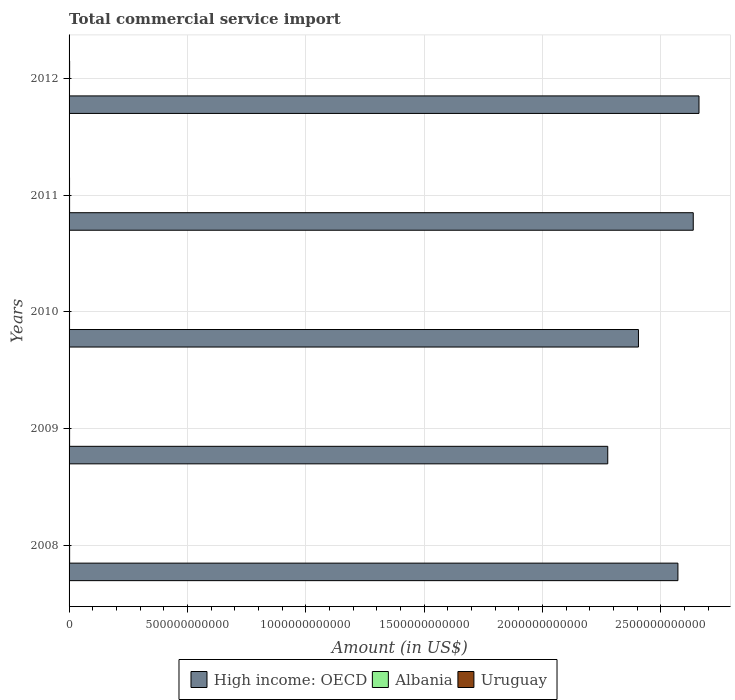Are the number of bars per tick equal to the number of legend labels?
Offer a very short reply. Yes. How many bars are there on the 1st tick from the top?
Provide a succinct answer. 3. In how many cases, is the number of bars for a given year not equal to the number of legend labels?
Ensure brevity in your answer.  0. What is the total commercial service import in Albania in 2011?
Your answer should be compact. 2.24e+09. Across all years, what is the maximum total commercial service import in Albania?
Make the answer very short. 2.35e+09. Across all years, what is the minimum total commercial service import in High income: OECD?
Your answer should be very brief. 2.28e+12. In which year was the total commercial service import in Uruguay minimum?
Offer a terse response. 2009. What is the total total commercial service import in High income: OECD in the graph?
Offer a very short reply. 1.26e+13. What is the difference between the total commercial service import in Uruguay in 2008 and that in 2012?
Make the answer very short. -8.85e+08. What is the difference between the total commercial service import in Uruguay in 2010 and the total commercial service import in High income: OECD in 2011?
Make the answer very short. -2.64e+12. What is the average total commercial service import in High income: OECD per year?
Offer a very short reply. 2.51e+12. In the year 2009, what is the difference between the total commercial service import in High income: OECD and total commercial service import in Albania?
Ensure brevity in your answer.  2.27e+12. In how many years, is the total commercial service import in High income: OECD greater than 300000000000 US$?
Ensure brevity in your answer.  5. What is the ratio of the total commercial service import in Albania in 2010 to that in 2012?
Your answer should be very brief. 1.07. Is the total commercial service import in High income: OECD in 2009 less than that in 2012?
Provide a short and direct response. Yes. Is the difference between the total commercial service import in High income: OECD in 2009 and 2010 greater than the difference between the total commercial service import in Albania in 2009 and 2010?
Provide a succinct answer. No. What is the difference between the highest and the second highest total commercial service import in Uruguay?
Keep it short and to the point. 3.33e+08. What is the difference between the highest and the lowest total commercial service import in Albania?
Provide a short and direct response. 4.93e+08. In how many years, is the total commercial service import in High income: OECD greater than the average total commercial service import in High income: OECD taken over all years?
Your answer should be compact. 3. What does the 1st bar from the top in 2009 represents?
Provide a short and direct response. Uruguay. What does the 3rd bar from the bottom in 2008 represents?
Give a very brief answer. Uruguay. How many bars are there?
Your response must be concise. 15. What is the difference between two consecutive major ticks on the X-axis?
Your answer should be compact. 5.00e+11. How are the legend labels stacked?
Keep it short and to the point. Horizontal. What is the title of the graph?
Make the answer very short. Total commercial service import. Does "Kenya" appear as one of the legend labels in the graph?
Keep it short and to the point. No. What is the Amount (in US$) of High income: OECD in 2008?
Make the answer very short. 2.57e+12. What is the Amount (in US$) in Albania in 2008?
Provide a succinct answer. 2.35e+09. What is the Amount (in US$) of Uruguay in 2008?
Ensure brevity in your answer.  1.46e+09. What is the Amount (in US$) of High income: OECD in 2009?
Your response must be concise. 2.28e+12. What is the Amount (in US$) of Albania in 2009?
Ensure brevity in your answer.  2.22e+09. What is the Amount (in US$) in Uruguay in 2009?
Your answer should be very brief. 1.23e+09. What is the Amount (in US$) of High income: OECD in 2010?
Offer a very short reply. 2.41e+12. What is the Amount (in US$) of Albania in 2010?
Make the answer very short. 1.99e+09. What is the Amount (in US$) of Uruguay in 2010?
Ensure brevity in your answer.  1.47e+09. What is the Amount (in US$) in High income: OECD in 2011?
Provide a short and direct response. 2.64e+12. What is the Amount (in US$) in Albania in 2011?
Offer a very short reply. 2.24e+09. What is the Amount (in US$) of Uruguay in 2011?
Keep it short and to the point. 2.01e+09. What is the Amount (in US$) of High income: OECD in 2012?
Your answer should be very brief. 2.66e+12. What is the Amount (in US$) of Albania in 2012?
Your answer should be compact. 1.86e+09. What is the Amount (in US$) of Uruguay in 2012?
Offer a terse response. 2.35e+09. Across all years, what is the maximum Amount (in US$) in High income: OECD?
Your answer should be compact. 2.66e+12. Across all years, what is the maximum Amount (in US$) in Albania?
Your answer should be compact. 2.35e+09. Across all years, what is the maximum Amount (in US$) in Uruguay?
Provide a short and direct response. 2.35e+09. Across all years, what is the minimum Amount (in US$) in High income: OECD?
Your answer should be very brief. 2.28e+12. Across all years, what is the minimum Amount (in US$) of Albania?
Your answer should be compact. 1.86e+09. Across all years, what is the minimum Amount (in US$) in Uruguay?
Keep it short and to the point. 1.23e+09. What is the total Amount (in US$) of High income: OECD in the graph?
Offer a terse response. 1.26e+13. What is the total Amount (in US$) in Albania in the graph?
Provide a succinct answer. 1.07e+1. What is the total Amount (in US$) of Uruguay in the graph?
Give a very brief answer. 8.53e+09. What is the difference between the Amount (in US$) of High income: OECD in 2008 and that in 2009?
Make the answer very short. 2.97e+11. What is the difference between the Amount (in US$) of Albania in 2008 and that in 2009?
Make the answer very short. 1.38e+08. What is the difference between the Amount (in US$) of Uruguay in 2008 and that in 2009?
Make the answer very short. 2.29e+08. What is the difference between the Amount (in US$) in High income: OECD in 2008 and that in 2010?
Your answer should be compact. 1.67e+11. What is the difference between the Amount (in US$) in Albania in 2008 and that in 2010?
Your answer should be very brief. 3.65e+08. What is the difference between the Amount (in US$) of Uruguay in 2008 and that in 2010?
Keep it short and to the point. -7.59e+06. What is the difference between the Amount (in US$) of High income: OECD in 2008 and that in 2011?
Your answer should be compact. -6.48e+1. What is the difference between the Amount (in US$) in Albania in 2008 and that in 2011?
Your answer should be compact. 1.18e+08. What is the difference between the Amount (in US$) in Uruguay in 2008 and that in 2011?
Your response must be concise. -5.52e+08. What is the difference between the Amount (in US$) in High income: OECD in 2008 and that in 2012?
Your response must be concise. -8.90e+1. What is the difference between the Amount (in US$) of Albania in 2008 and that in 2012?
Ensure brevity in your answer.  4.93e+08. What is the difference between the Amount (in US$) in Uruguay in 2008 and that in 2012?
Keep it short and to the point. -8.85e+08. What is the difference between the Amount (in US$) in High income: OECD in 2009 and that in 2010?
Provide a short and direct response. -1.30e+11. What is the difference between the Amount (in US$) in Albania in 2009 and that in 2010?
Keep it short and to the point. 2.27e+08. What is the difference between the Amount (in US$) of Uruguay in 2009 and that in 2010?
Your answer should be very brief. -2.36e+08. What is the difference between the Amount (in US$) in High income: OECD in 2009 and that in 2011?
Give a very brief answer. -3.61e+11. What is the difference between the Amount (in US$) of Albania in 2009 and that in 2011?
Provide a short and direct response. -1.96e+07. What is the difference between the Amount (in US$) of Uruguay in 2009 and that in 2011?
Make the answer very short. -7.80e+08. What is the difference between the Amount (in US$) of High income: OECD in 2009 and that in 2012?
Offer a terse response. -3.86e+11. What is the difference between the Amount (in US$) in Albania in 2009 and that in 2012?
Provide a succinct answer. 3.55e+08. What is the difference between the Amount (in US$) of Uruguay in 2009 and that in 2012?
Your answer should be compact. -1.11e+09. What is the difference between the Amount (in US$) in High income: OECD in 2010 and that in 2011?
Give a very brief answer. -2.32e+11. What is the difference between the Amount (in US$) in Albania in 2010 and that in 2011?
Give a very brief answer. -2.47e+08. What is the difference between the Amount (in US$) of Uruguay in 2010 and that in 2011?
Make the answer very short. -5.44e+08. What is the difference between the Amount (in US$) in High income: OECD in 2010 and that in 2012?
Give a very brief answer. -2.56e+11. What is the difference between the Amount (in US$) in Albania in 2010 and that in 2012?
Offer a very short reply. 1.28e+08. What is the difference between the Amount (in US$) in Uruguay in 2010 and that in 2012?
Give a very brief answer. -8.77e+08. What is the difference between the Amount (in US$) of High income: OECD in 2011 and that in 2012?
Your answer should be compact. -2.43e+1. What is the difference between the Amount (in US$) in Albania in 2011 and that in 2012?
Provide a short and direct response. 3.75e+08. What is the difference between the Amount (in US$) in Uruguay in 2011 and that in 2012?
Make the answer very short. -3.33e+08. What is the difference between the Amount (in US$) of High income: OECD in 2008 and the Amount (in US$) of Albania in 2009?
Your answer should be very brief. 2.57e+12. What is the difference between the Amount (in US$) in High income: OECD in 2008 and the Amount (in US$) in Uruguay in 2009?
Offer a very short reply. 2.57e+12. What is the difference between the Amount (in US$) in Albania in 2008 and the Amount (in US$) in Uruguay in 2009?
Ensure brevity in your answer.  1.12e+09. What is the difference between the Amount (in US$) of High income: OECD in 2008 and the Amount (in US$) of Albania in 2010?
Your response must be concise. 2.57e+12. What is the difference between the Amount (in US$) in High income: OECD in 2008 and the Amount (in US$) in Uruguay in 2010?
Keep it short and to the point. 2.57e+12. What is the difference between the Amount (in US$) in Albania in 2008 and the Amount (in US$) in Uruguay in 2010?
Give a very brief answer. 8.84e+08. What is the difference between the Amount (in US$) in High income: OECD in 2008 and the Amount (in US$) in Albania in 2011?
Offer a very short reply. 2.57e+12. What is the difference between the Amount (in US$) of High income: OECD in 2008 and the Amount (in US$) of Uruguay in 2011?
Your response must be concise. 2.57e+12. What is the difference between the Amount (in US$) of Albania in 2008 and the Amount (in US$) of Uruguay in 2011?
Provide a short and direct response. 3.40e+08. What is the difference between the Amount (in US$) of High income: OECD in 2008 and the Amount (in US$) of Albania in 2012?
Offer a terse response. 2.57e+12. What is the difference between the Amount (in US$) in High income: OECD in 2008 and the Amount (in US$) in Uruguay in 2012?
Your response must be concise. 2.57e+12. What is the difference between the Amount (in US$) in Albania in 2008 and the Amount (in US$) in Uruguay in 2012?
Ensure brevity in your answer.  6.91e+06. What is the difference between the Amount (in US$) of High income: OECD in 2009 and the Amount (in US$) of Albania in 2010?
Offer a very short reply. 2.27e+12. What is the difference between the Amount (in US$) of High income: OECD in 2009 and the Amount (in US$) of Uruguay in 2010?
Make the answer very short. 2.27e+12. What is the difference between the Amount (in US$) of Albania in 2009 and the Amount (in US$) of Uruguay in 2010?
Offer a very short reply. 7.46e+08. What is the difference between the Amount (in US$) in High income: OECD in 2009 and the Amount (in US$) in Albania in 2011?
Offer a terse response. 2.27e+12. What is the difference between the Amount (in US$) of High income: OECD in 2009 and the Amount (in US$) of Uruguay in 2011?
Offer a terse response. 2.27e+12. What is the difference between the Amount (in US$) of Albania in 2009 and the Amount (in US$) of Uruguay in 2011?
Keep it short and to the point. 2.02e+08. What is the difference between the Amount (in US$) of High income: OECD in 2009 and the Amount (in US$) of Albania in 2012?
Your answer should be very brief. 2.27e+12. What is the difference between the Amount (in US$) of High income: OECD in 2009 and the Amount (in US$) of Uruguay in 2012?
Ensure brevity in your answer.  2.27e+12. What is the difference between the Amount (in US$) of Albania in 2009 and the Amount (in US$) of Uruguay in 2012?
Offer a terse response. -1.31e+08. What is the difference between the Amount (in US$) of High income: OECD in 2010 and the Amount (in US$) of Albania in 2011?
Provide a short and direct response. 2.40e+12. What is the difference between the Amount (in US$) of High income: OECD in 2010 and the Amount (in US$) of Uruguay in 2011?
Provide a succinct answer. 2.40e+12. What is the difference between the Amount (in US$) in Albania in 2010 and the Amount (in US$) in Uruguay in 2011?
Make the answer very short. -2.49e+07. What is the difference between the Amount (in US$) in High income: OECD in 2010 and the Amount (in US$) in Albania in 2012?
Offer a very short reply. 2.40e+12. What is the difference between the Amount (in US$) of High income: OECD in 2010 and the Amount (in US$) of Uruguay in 2012?
Keep it short and to the point. 2.40e+12. What is the difference between the Amount (in US$) of Albania in 2010 and the Amount (in US$) of Uruguay in 2012?
Provide a succinct answer. -3.58e+08. What is the difference between the Amount (in US$) of High income: OECD in 2011 and the Amount (in US$) of Albania in 2012?
Provide a succinct answer. 2.64e+12. What is the difference between the Amount (in US$) of High income: OECD in 2011 and the Amount (in US$) of Uruguay in 2012?
Give a very brief answer. 2.64e+12. What is the difference between the Amount (in US$) in Albania in 2011 and the Amount (in US$) in Uruguay in 2012?
Give a very brief answer. -1.12e+08. What is the average Amount (in US$) in High income: OECD per year?
Make the answer very short. 2.51e+12. What is the average Amount (in US$) of Albania per year?
Keep it short and to the point. 2.13e+09. What is the average Amount (in US$) in Uruguay per year?
Provide a succinct answer. 1.71e+09. In the year 2008, what is the difference between the Amount (in US$) of High income: OECD and Amount (in US$) of Albania?
Your answer should be compact. 2.57e+12. In the year 2008, what is the difference between the Amount (in US$) of High income: OECD and Amount (in US$) of Uruguay?
Your answer should be compact. 2.57e+12. In the year 2008, what is the difference between the Amount (in US$) in Albania and Amount (in US$) in Uruguay?
Provide a short and direct response. 8.92e+08. In the year 2009, what is the difference between the Amount (in US$) of High income: OECD and Amount (in US$) of Albania?
Your answer should be compact. 2.27e+12. In the year 2009, what is the difference between the Amount (in US$) of High income: OECD and Amount (in US$) of Uruguay?
Ensure brevity in your answer.  2.28e+12. In the year 2009, what is the difference between the Amount (in US$) of Albania and Amount (in US$) of Uruguay?
Ensure brevity in your answer.  9.83e+08. In the year 2010, what is the difference between the Amount (in US$) of High income: OECD and Amount (in US$) of Albania?
Keep it short and to the point. 2.40e+12. In the year 2010, what is the difference between the Amount (in US$) of High income: OECD and Amount (in US$) of Uruguay?
Your response must be concise. 2.40e+12. In the year 2010, what is the difference between the Amount (in US$) in Albania and Amount (in US$) in Uruguay?
Offer a very short reply. 5.19e+08. In the year 2011, what is the difference between the Amount (in US$) of High income: OECD and Amount (in US$) of Albania?
Give a very brief answer. 2.64e+12. In the year 2011, what is the difference between the Amount (in US$) in High income: OECD and Amount (in US$) in Uruguay?
Offer a very short reply. 2.64e+12. In the year 2011, what is the difference between the Amount (in US$) of Albania and Amount (in US$) of Uruguay?
Provide a short and direct response. 2.22e+08. In the year 2012, what is the difference between the Amount (in US$) in High income: OECD and Amount (in US$) in Albania?
Make the answer very short. 2.66e+12. In the year 2012, what is the difference between the Amount (in US$) in High income: OECD and Amount (in US$) in Uruguay?
Offer a very short reply. 2.66e+12. In the year 2012, what is the difference between the Amount (in US$) in Albania and Amount (in US$) in Uruguay?
Your answer should be very brief. -4.86e+08. What is the ratio of the Amount (in US$) of High income: OECD in 2008 to that in 2009?
Offer a terse response. 1.13. What is the ratio of the Amount (in US$) in Albania in 2008 to that in 2009?
Offer a very short reply. 1.06. What is the ratio of the Amount (in US$) in Uruguay in 2008 to that in 2009?
Make the answer very short. 1.19. What is the ratio of the Amount (in US$) in High income: OECD in 2008 to that in 2010?
Your response must be concise. 1.07. What is the ratio of the Amount (in US$) in Albania in 2008 to that in 2010?
Ensure brevity in your answer.  1.18. What is the ratio of the Amount (in US$) of High income: OECD in 2008 to that in 2011?
Make the answer very short. 0.98. What is the ratio of the Amount (in US$) in Albania in 2008 to that in 2011?
Make the answer very short. 1.05. What is the ratio of the Amount (in US$) in Uruguay in 2008 to that in 2011?
Offer a very short reply. 0.73. What is the ratio of the Amount (in US$) in High income: OECD in 2008 to that in 2012?
Your response must be concise. 0.97. What is the ratio of the Amount (in US$) in Albania in 2008 to that in 2012?
Give a very brief answer. 1.27. What is the ratio of the Amount (in US$) of Uruguay in 2008 to that in 2012?
Ensure brevity in your answer.  0.62. What is the ratio of the Amount (in US$) of High income: OECD in 2009 to that in 2010?
Keep it short and to the point. 0.95. What is the ratio of the Amount (in US$) in Albania in 2009 to that in 2010?
Provide a succinct answer. 1.11. What is the ratio of the Amount (in US$) in Uruguay in 2009 to that in 2010?
Your answer should be compact. 0.84. What is the ratio of the Amount (in US$) of High income: OECD in 2009 to that in 2011?
Give a very brief answer. 0.86. What is the ratio of the Amount (in US$) in Albania in 2009 to that in 2011?
Ensure brevity in your answer.  0.99. What is the ratio of the Amount (in US$) in Uruguay in 2009 to that in 2011?
Offer a very short reply. 0.61. What is the ratio of the Amount (in US$) in High income: OECD in 2009 to that in 2012?
Offer a terse response. 0.86. What is the ratio of the Amount (in US$) in Albania in 2009 to that in 2012?
Your answer should be compact. 1.19. What is the ratio of the Amount (in US$) in Uruguay in 2009 to that in 2012?
Provide a short and direct response. 0.53. What is the ratio of the Amount (in US$) of High income: OECD in 2010 to that in 2011?
Offer a terse response. 0.91. What is the ratio of the Amount (in US$) of Albania in 2010 to that in 2011?
Offer a very short reply. 0.89. What is the ratio of the Amount (in US$) of Uruguay in 2010 to that in 2011?
Your answer should be compact. 0.73. What is the ratio of the Amount (in US$) in High income: OECD in 2010 to that in 2012?
Your response must be concise. 0.9. What is the ratio of the Amount (in US$) of Albania in 2010 to that in 2012?
Offer a very short reply. 1.07. What is the ratio of the Amount (in US$) in Uruguay in 2010 to that in 2012?
Offer a terse response. 0.63. What is the ratio of the Amount (in US$) in High income: OECD in 2011 to that in 2012?
Give a very brief answer. 0.99. What is the ratio of the Amount (in US$) in Albania in 2011 to that in 2012?
Keep it short and to the point. 1.2. What is the ratio of the Amount (in US$) in Uruguay in 2011 to that in 2012?
Keep it short and to the point. 0.86. What is the difference between the highest and the second highest Amount (in US$) of High income: OECD?
Keep it short and to the point. 2.43e+1. What is the difference between the highest and the second highest Amount (in US$) in Albania?
Keep it short and to the point. 1.18e+08. What is the difference between the highest and the second highest Amount (in US$) of Uruguay?
Give a very brief answer. 3.33e+08. What is the difference between the highest and the lowest Amount (in US$) in High income: OECD?
Provide a short and direct response. 3.86e+11. What is the difference between the highest and the lowest Amount (in US$) in Albania?
Make the answer very short. 4.93e+08. What is the difference between the highest and the lowest Amount (in US$) in Uruguay?
Offer a terse response. 1.11e+09. 